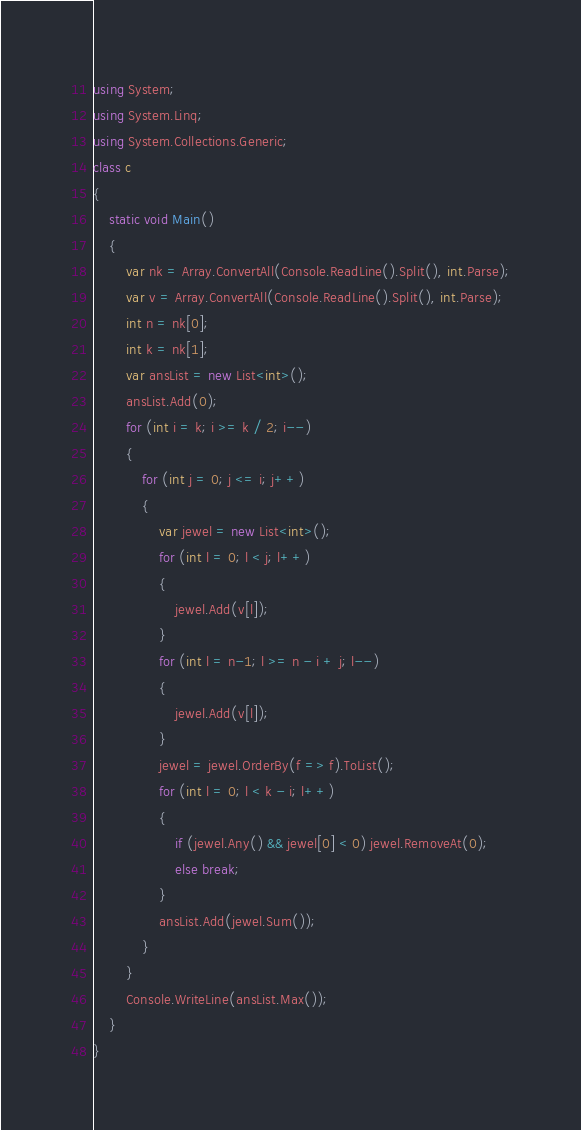<code> <loc_0><loc_0><loc_500><loc_500><_C#_>using System;
using System.Linq;
using System.Collections.Generic;
class c
{
    static void Main()
    {
        var nk = Array.ConvertAll(Console.ReadLine().Split(), int.Parse);
        var v = Array.ConvertAll(Console.ReadLine().Split(), int.Parse);
        int n = nk[0];
        int k = nk[1];
        var ansList = new List<int>();
        ansList.Add(0);
        for (int i = k; i >= k / 2; i--)
        {
            for (int j = 0; j <= i; j++)
            {
                var jewel = new List<int>();
                for (int l = 0; l < j; l++)
                {
                    jewel.Add(v[l]);
                }
                for (int l = n-1; l >= n - i + j; l--)
                {
                    jewel.Add(v[l]);
                }
                jewel = jewel.OrderBy(f => f).ToList();
                for (int l = 0; l < k - i; l++)
                {
                    if (jewel.Any() && jewel[0] < 0) jewel.RemoveAt(0);
                    else break;
                }
                ansList.Add(jewel.Sum());
            }
        }
        Console.WriteLine(ansList.Max());
    }
}</code> 